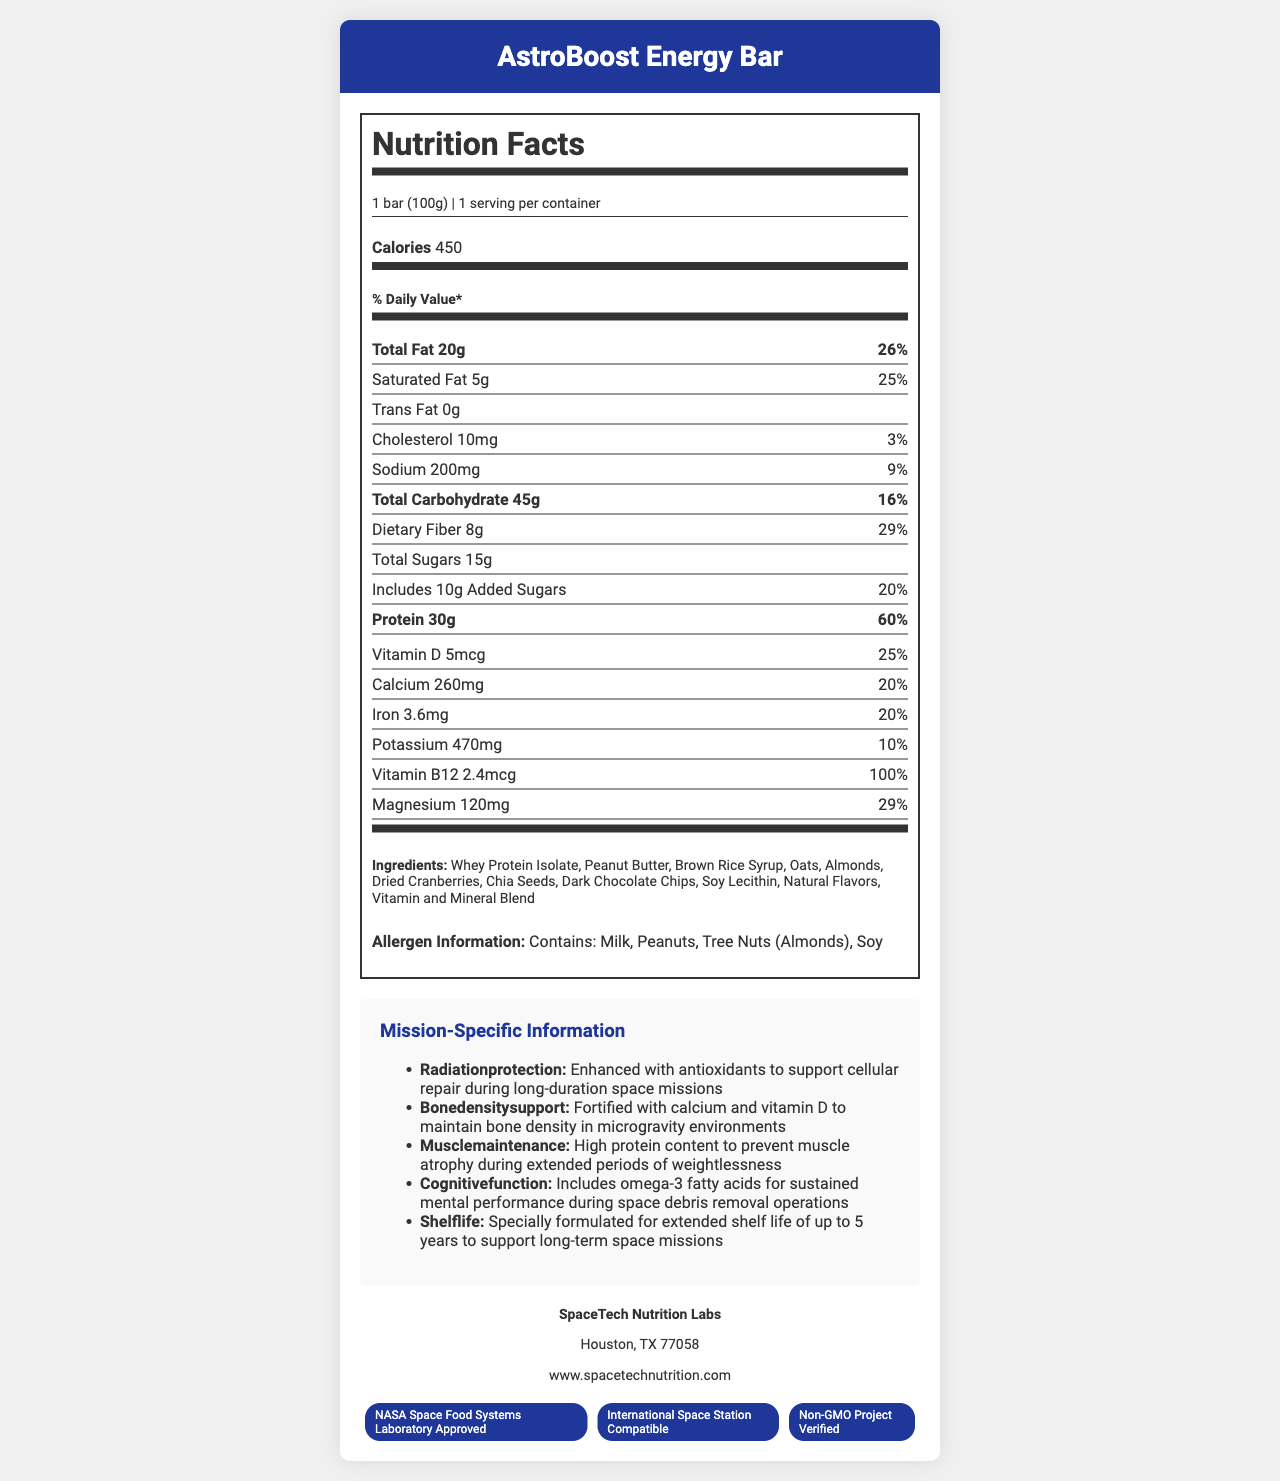what is the serving size? The serving size is explicitly mentioned in the "serving size" part of the document.
Answer: 1 bar (100g) how many calories are there per serving? The number of calories per serving is listed under "calories per serving."
Answer: 450 what percentage of the daily value of protein does this bar provide? The protein daily value percentage is stated next to the protein content.
Answer: 60% what ingredients are included in the AstroBoost Energy Bar? The ingredients are listed in the ingredients section of the document.
Answer: Whey Protein Isolate, Peanut Butter, Brown Rice Syrup, Oats, Almonds, Dried Cranberries, Chia Seeds, Dark Chocolate Chips, Soy Lecithin, Natural Flavors, Vitamin and Mineral Blend what vitamins and minerals are included in the AstroBoost Energy Bar and their percentages of daily value? The document has a section listing the vitamins and minerals and their respective percentages of daily value.
Answer: Vitamin D (25%), Calcium (20%), Iron (20%), Potassium (10%), Vitamin B12 (100%), Magnesium (29%) how much dietary fiber does this energy bar contain? A. 5g B. 8g C. 10g The dietary fiber content, 8g, is mentioned in its respective section under total carbohydrate.
Answer: B which certification is NOT mentioned for the AstroBoost Energy Bar? I. Non-GMO Project Verified II. USDA Organic III. NASA Space Food Systems Laboratory Approved IV. International Space Station Compatible The certifications listed are NASA Space Food Systems Laboratory Approved, International Space Station Compatible, and Non-GMO Project Verified. USDA Organic is not mentioned.
Answer: II. USDA Organic is there any cholesterol in the product? The document specifies that the energy bar contains 10mg of cholesterol.
Answer: Yes is the product suitable for individuals with peanut allergies? The allergen statement indicates that the product contains peanuts.
Answer: No summarize the key nutritional and mission-specific highlights of the AstroBoost Energy Bar. The document highlights the bar’s nutritional contents, including high protein and essential vitamins and minerals, designed to support astronauts' health during long-term missions, with special certifications and an allergen statement.
Answer: The AstroBoost Energy Bar provides 450 calories per serving with 20g of total fat, 30g of protein, and a variety of vitamins and minerals like Vitamin D, Calcium, Iron, Vitamin B12, and Magnesium. It's enriched for long-duration space missions with enhanced antioxidants, calcium and vitamin D for bone density support, and omega-3 fatty acids for cognitive function. The product has extended shelf life and is certified by NASA Space Food Systems Laboratory, ISS compatible, and Non-GMO verified. who manufactures the AstroBoost Energy Bar? The manufacturer’s information is provided at the bottom of the document.
Answer: SpaceTech Nutrition Labs how long is the shelf life of the AstroBoost Energy Bar? The document states that the energy bar has a specially formulated extended shelf life of up to 5 years.
Answer: 5 years what is the source of omega-3 fatty acids in the AstroBoost Energy Bar? The document mentions the inclusion of omega-3 fatty acids for cognitive function, but it does not state the source of these fatty acids.
Answer: Cannot be determined what is the calorie contribution from fat if each gram of fat provides 9 calories? A. 180 calories B. 240 calories C. 300 calories D. 360 calories The total fat is 20g. Each gram of fat provides 9 calories, so 20g * 9 calories/g = 180 calories. Thus, the answer is 180 calories.
Answer: B. 240 calories 